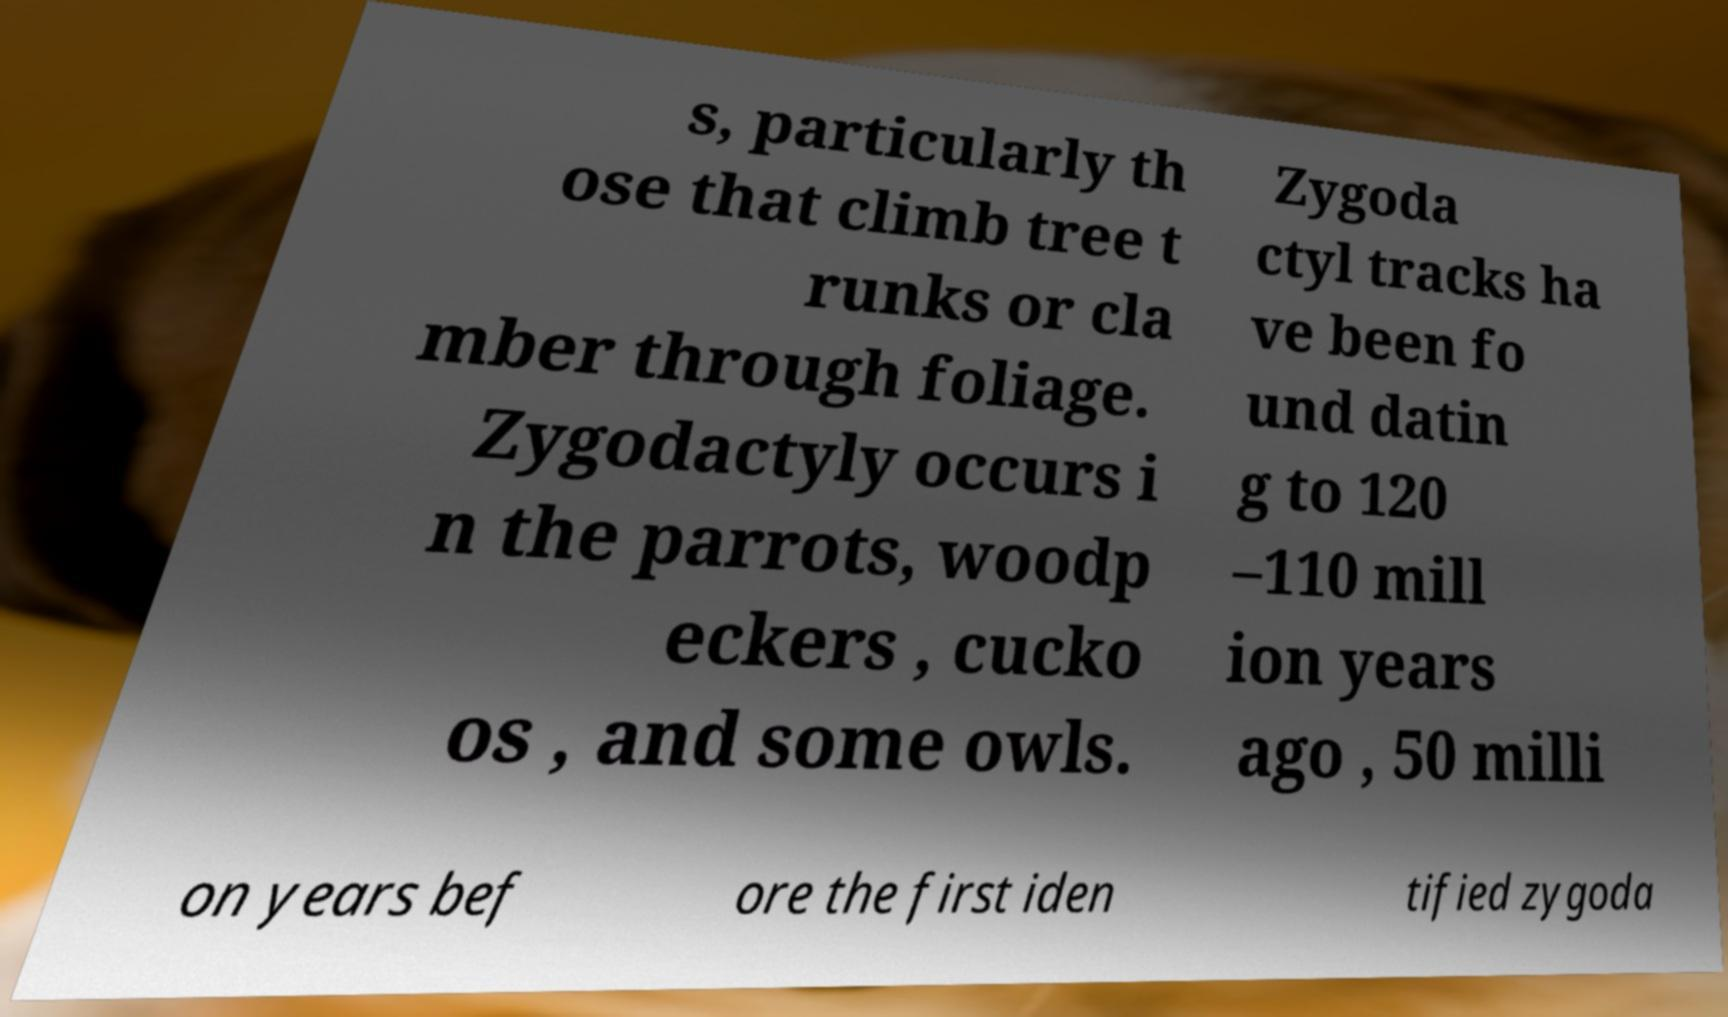Please read and relay the text visible in this image. What does it say? s, particularly th ose that climb tree t runks or cla mber through foliage. Zygodactyly occurs i n the parrots, woodp eckers , cucko os , and some owls. Zygoda ctyl tracks ha ve been fo und datin g to 120 –110 mill ion years ago , 50 milli on years bef ore the first iden tified zygoda 